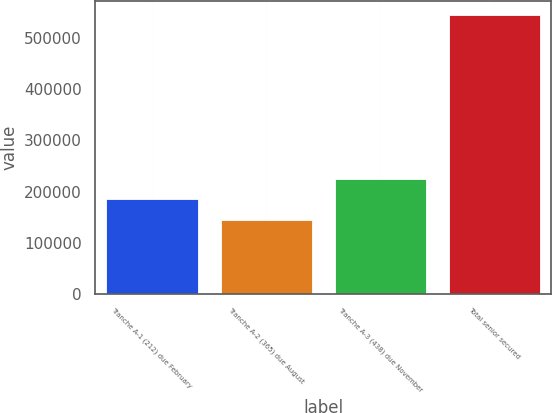Convert chart. <chart><loc_0><loc_0><loc_500><loc_500><bar_chart><fcel>Tranche A-1 (212) due February<fcel>Tranche A-2 (365) due August<fcel>Tranche A-3 (438) due November<fcel>Total senior secured<nl><fcel>184910<fcel>144800<fcel>225020<fcel>545900<nl></chart> 